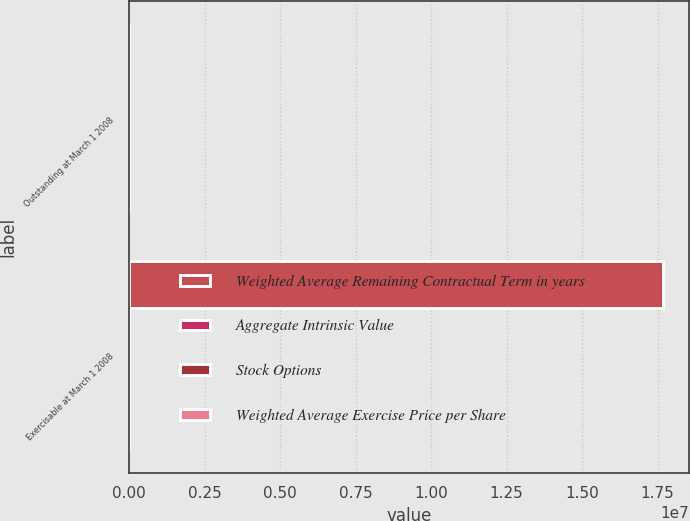Convert chart. <chart><loc_0><loc_0><loc_500><loc_500><stacked_bar_chart><ecel><fcel>Outstanding at March 1 2008<fcel>Exercisable at March 1 2008<nl><fcel>Weighted Average Remaining Contractual Term in years<fcel>39.73<fcel>1.7675e+07<nl><fcel>Aggregate Intrinsic Value<fcel>39.73<fcel>34<nl><fcel>Stock Options<fcel>6.35<fcel>4.8<nl><fcel>Weighted Average Exercise Price per Share<fcel>186<fcel>180<nl></chart> 